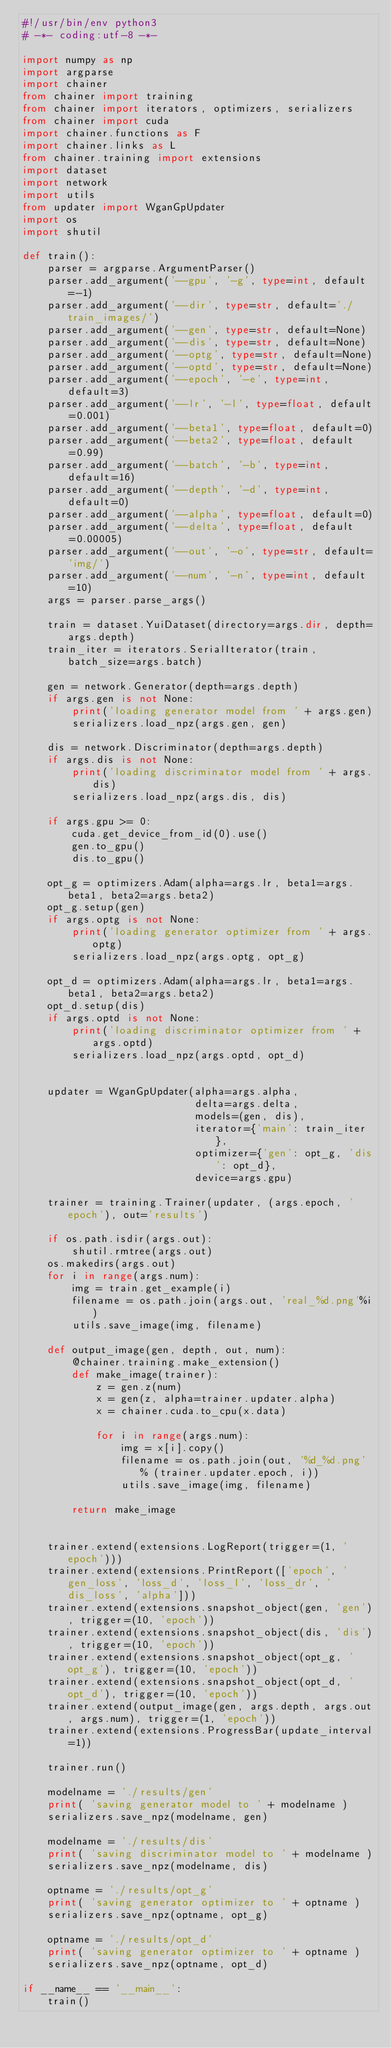Convert code to text. <code><loc_0><loc_0><loc_500><loc_500><_Python_>#!/usr/bin/env python3
# -*- coding:utf-8 -*-

import numpy as np
import argparse
import chainer
from chainer import training
from chainer import iterators, optimizers, serializers
from chainer import cuda
import chainer.functions as F
import chainer.links as L
from chainer.training import extensions
import dataset
import network
import utils
from updater import WganGpUpdater
import os
import shutil

def train():
    parser = argparse.ArgumentParser()
    parser.add_argument('--gpu', '-g', type=int, default=-1)
    parser.add_argument('--dir', type=str, default='./train_images/')
    parser.add_argument('--gen', type=str, default=None)
    parser.add_argument('--dis', type=str, default=None)
    parser.add_argument('--optg', type=str, default=None)
    parser.add_argument('--optd', type=str, default=None)
    parser.add_argument('--epoch', '-e', type=int, default=3)
    parser.add_argument('--lr', '-l', type=float, default=0.001)
    parser.add_argument('--beta1', type=float, default=0)
    parser.add_argument('--beta2', type=float, default=0.99)
    parser.add_argument('--batch', '-b', type=int, default=16)
    parser.add_argument('--depth', '-d', type=int, default=0)
    parser.add_argument('--alpha', type=float, default=0)
    parser.add_argument('--delta', type=float, default=0.00005)
    parser.add_argument('--out', '-o', type=str, default='img/')
    parser.add_argument('--num', '-n', type=int, default=10)
    args = parser.parse_args()

    train = dataset.YuiDataset(directory=args.dir, depth=args.depth)
    train_iter = iterators.SerialIterator(train, batch_size=args.batch)

    gen = network.Generator(depth=args.depth)
    if args.gen is not None:
        print('loading generator model from ' + args.gen)
        serializers.load_npz(args.gen, gen)

    dis = network.Discriminator(depth=args.depth)
    if args.dis is not None:
        print('loading discriminator model from ' + args.dis)
        serializers.load_npz(args.dis, dis)
        
    if args.gpu >= 0:
        cuda.get_device_from_id(0).use()
        gen.to_gpu()
        dis.to_gpu()

    opt_g = optimizers.Adam(alpha=args.lr, beta1=args.beta1, beta2=args.beta2)
    opt_g.setup(gen)
    if args.optg is not None:
        print('loading generator optimizer from ' + args.optg)
        serializers.load_npz(args.optg, opt_g)
    
    opt_d = optimizers.Adam(alpha=args.lr, beta1=args.beta1, beta2=args.beta2)
    opt_d.setup(dis)
    if args.optd is not None:
        print('loading discriminator optimizer from ' + args.optd)
        serializers.load_npz(args.optd, opt_d)


    updater = WganGpUpdater(alpha=args.alpha,
                            delta=args.delta,
                            models=(gen, dis),
                            iterator={'main': train_iter},
                            optimizer={'gen': opt_g, 'dis': opt_d},
                            device=args.gpu)

    trainer = training.Trainer(updater, (args.epoch, 'epoch'), out='results')

    if os.path.isdir(args.out):
        shutil.rmtree(args.out)
    os.makedirs(args.out)
    for i in range(args.num):
        img = train.get_example(i)
        filename = os.path.join(args.out, 'real_%d.png'%i)
        utils.save_image(img, filename)
    
    def output_image(gen, depth, out, num):
        @chainer.training.make_extension()
        def make_image(trainer):
            z = gen.z(num)
            x = gen(z, alpha=trainer.updater.alpha)
            x = chainer.cuda.to_cpu(x.data)

            for i in range(args.num):
                img = x[i].copy()
                filename = os.path.join(out, '%d_%d.png' % (trainer.updater.epoch, i))
                utils.save_image(img, filename)

        return make_image
            
    
    trainer.extend(extensions.LogReport(trigger=(1, 'epoch')))
    trainer.extend(extensions.PrintReport(['epoch', 'gen_loss', 'loss_d', 'loss_l', 'loss_dr', 'dis_loss', 'alpha']))
    trainer.extend(extensions.snapshot_object(gen, 'gen'), trigger=(10, 'epoch'))
    trainer.extend(extensions.snapshot_object(dis, 'dis'), trigger=(10, 'epoch'))
    trainer.extend(extensions.snapshot_object(opt_g, 'opt_g'), trigger=(10, 'epoch'))
    trainer.extend(extensions.snapshot_object(opt_d, 'opt_d'), trigger=(10, 'epoch'))
    trainer.extend(output_image(gen, args.depth, args.out, args.num), trigger=(1, 'epoch'))
    trainer.extend(extensions.ProgressBar(update_interval=1))    
    
    trainer.run()

    modelname = './results/gen'
    print( 'saving generator model to ' + modelname )
    serializers.save_npz(modelname, gen)

    modelname = './results/dis'
    print( 'saving discriminator model to ' + modelname )
    serializers.save_npz(modelname, dis)

    optname = './results/opt_g'
    print( 'saving generator optimizer to ' + optname )
    serializers.save_npz(optname, opt_g)

    optname = './results/opt_d'
    print( 'saving generator optimizer to ' + optname )
    serializers.save_npz(optname, opt_d)

if __name__ == '__main__':
    train()
</code> 